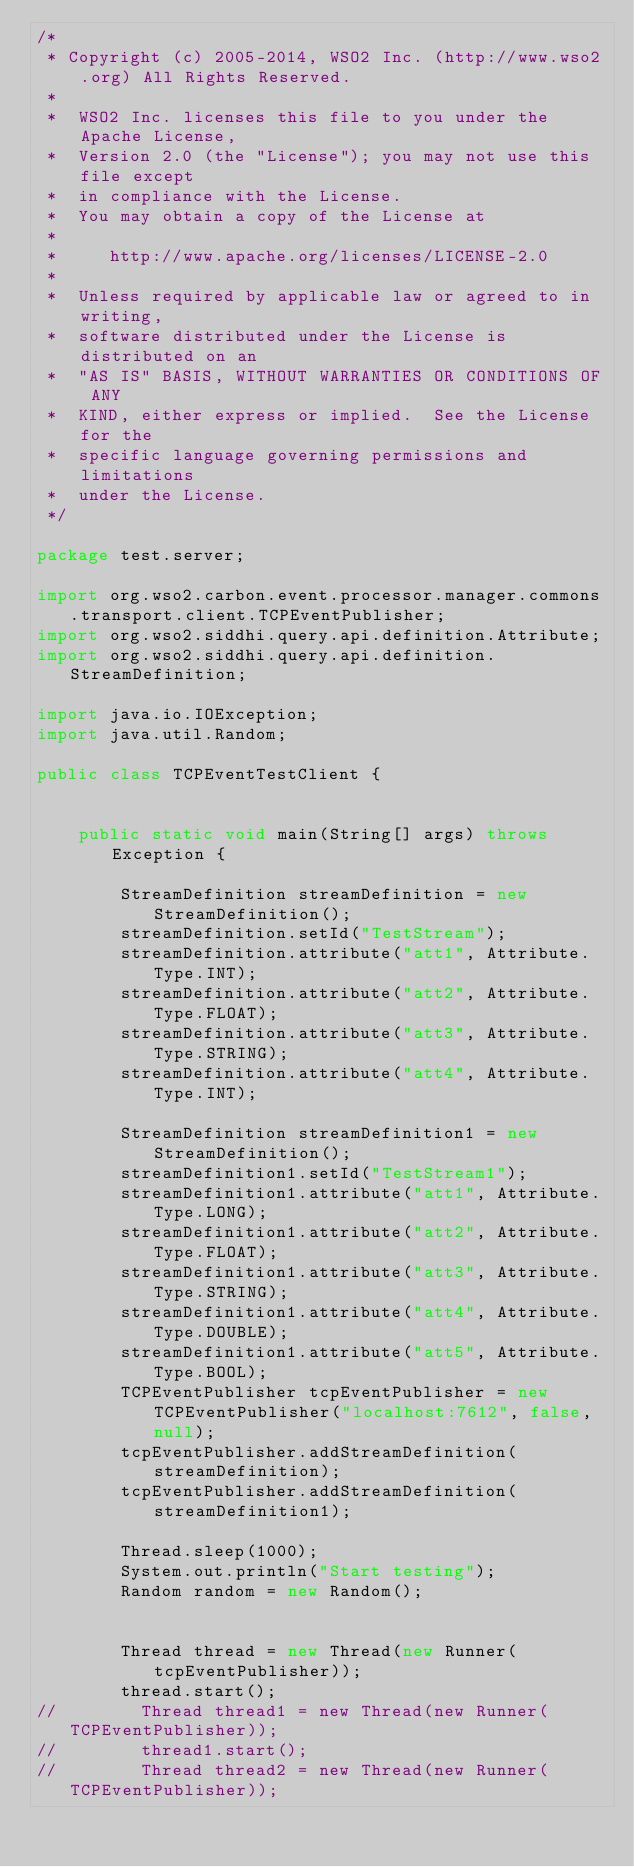Convert code to text. <code><loc_0><loc_0><loc_500><loc_500><_Java_>/*
 * Copyright (c) 2005-2014, WSO2 Inc. (http://www.wso2.org) All Rights Reserved.
 *
 *  WSO2 Inc. licenses this file to you under the Apache License,
 *  Version 2.0 (the "License"); you may not use this file except
 *  in compliance with the License.
 *  You may obtain a copy of the License at
 *
 *     http://www.apache.org/licenses/LICENSE-2.0
 *
 *  Unless required by applicable law or agreed to in writing,
 *  software distributed under the License is distributed on an
 *  "AS IS" BASIS, WITHOUT WARRANTIES OR CONDITIONS OF ANY
 *  KIND, either express or implied.  See the License for the
 *  specific language governing permissions and limitations
 *  under the License.
 */

package test.server;

import org.wso2.carbon.event.processor.manager.commons.transport.client.TCPEventPublisher;
import org.wso2.siddhi.query.api.definition.Attribute;
import org.wso2.siddhi.query.api.definition.StreamDefinition;

import java.io.IOException;
import java.util.Random;

public class TCPEventTestClient {


    public static void main(String[] args) throws Exception {

        StreamDefinition streamDefinition = new StreamDefinition();
        streamDefinition.setId("TestStream");
        streamDefinition.attribute("att1", Attribute.Type.INT);
        streamDefinition.attribute("att2", Attribute.Type.FLOAT);
        streamDefinition.attribute("att3", Attribute.Type.STRING);
        streamDefinition.attribute("att4", Attribute.Type.INT);

        StreamDefinition streamDefinition1 = new StreamDefinition();
        streamDefinition1.setId("TestStream1");
        streamDefinition1.attribute("att1", Attribute.Type.LONG);
        streamDefinition1.attribute("att2", Attribute.Type.FLOAT);
        streamDefinition1.attribute("att3", Attribute.Type.STRING);
        streamDefinition1.attribute("att4", Attribute.Type.DOUBLE);
        streamDefinition1.attribute("att5", Attribute.Type.BOOL);
        TCPEventPublisher tcpEventPublisher = new TCPEventPublisher("localhost:7612", false, null);
        tcpEventPublisher.addStreamDefinition(streamDefinition);
        tcpEventPublisher.addStreamDefinition(streamDefinition1);

        Thread.sleep(1000);
        System.out.println("Start testing");
        Random random = new Random();


        Thread thread = new Thread(new Runner(tcpEventPublisher));
        thread.start();
//        Thread thread1 = new Thread(new Runner(TCPEventPublisher));
//        thread1.start();
//        Thread thread2 = new Thread(new Runner(TCPEventPublisher));</code> 